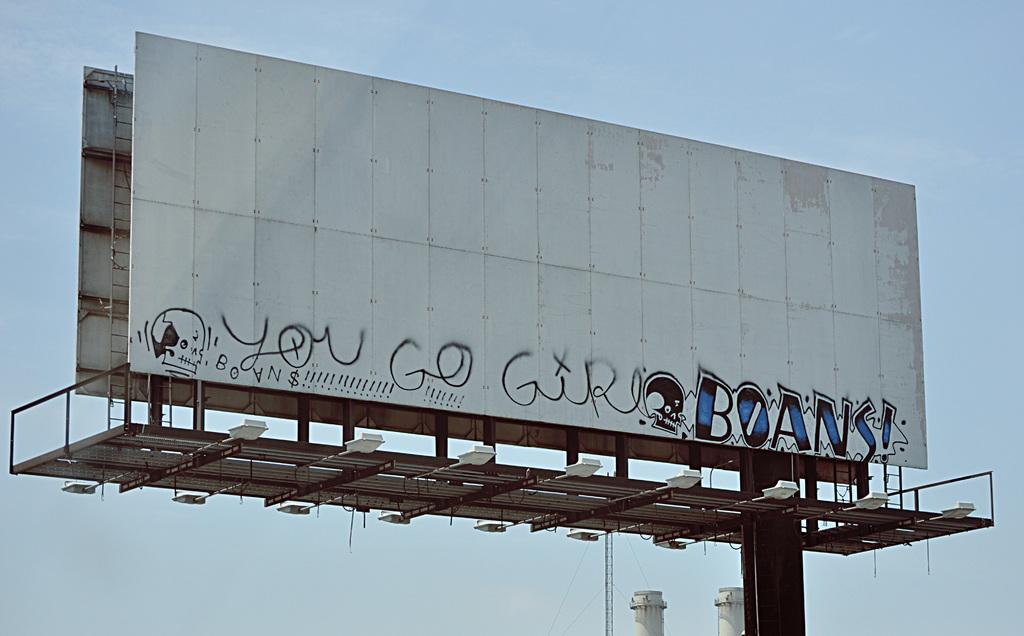<image>
Summarize the visual content of the image. Graffiti scribbled on an empty billboard saying "you go" 